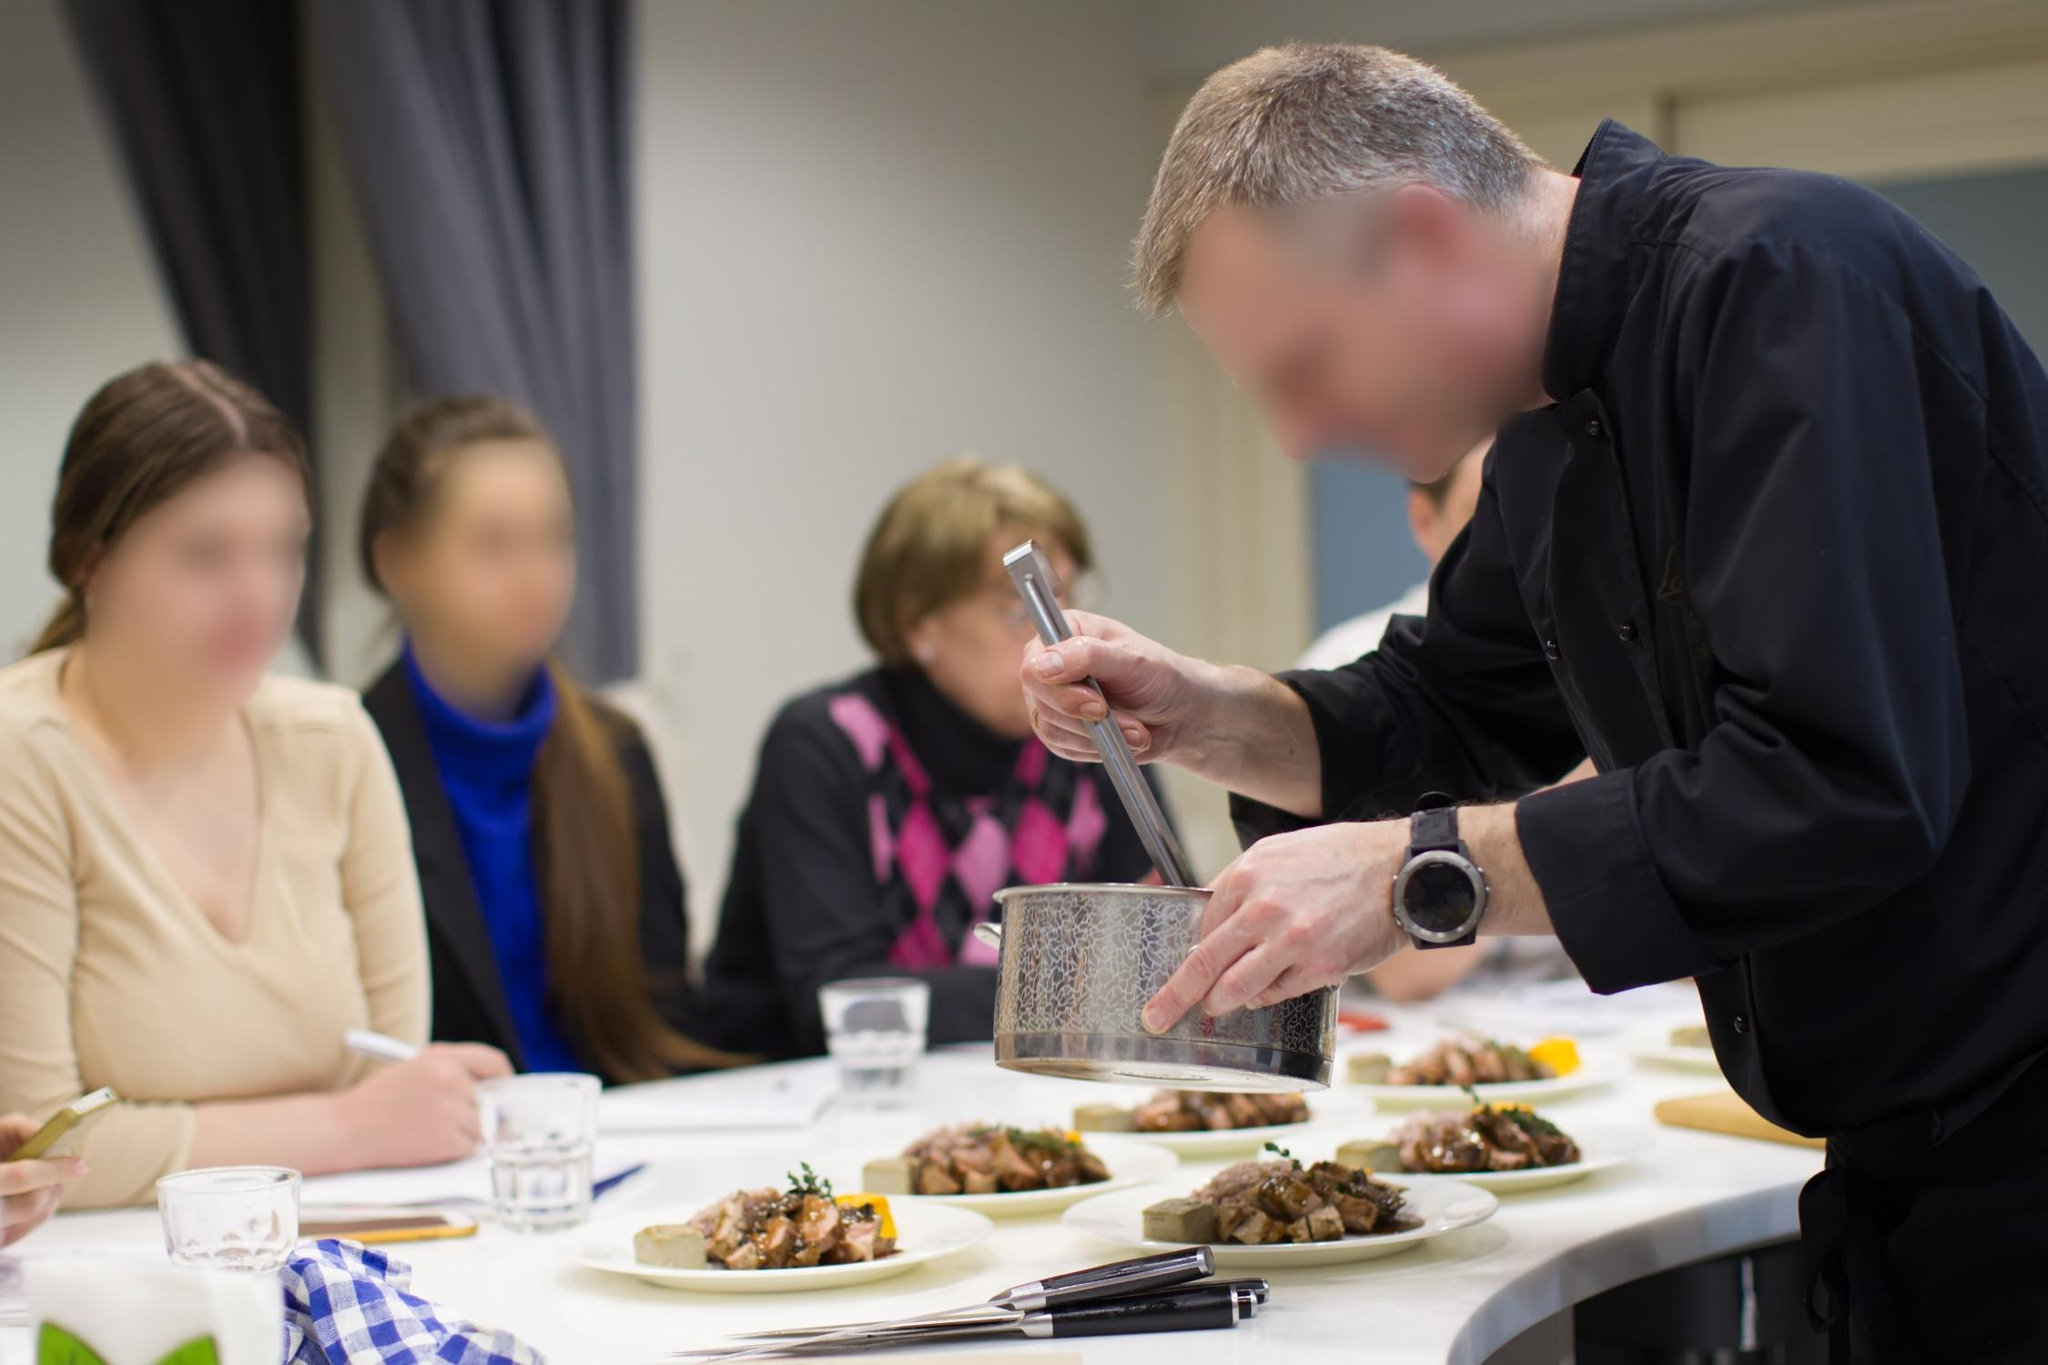What details can you observe about the chef's preparation process? The chef appears to be highly focused and precise in his preparation. He is using a large silver grater to evenly distribute cheese over a dish, ensuring a consistent and professional presentation. The counter is neat and organized with plates of food, utensils, and an aesthetically pleasing blue and white checkered tablecloth. The setting suggests a well-thought-out and methodical approach to culinary art, allowing the chef to perform smoothly and efficiently. 